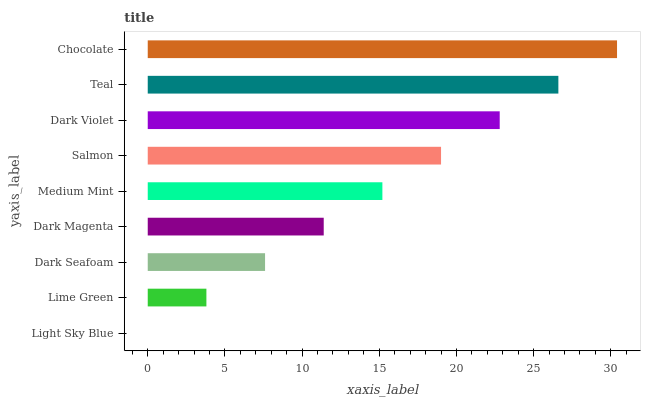Is Light Sky Blue the minimum?
Answer yes or no. Yes. Is Chocolate the maximum?
Answer yes or no. Yes. Is Lime Green the minimum?
Answer yes or no. No. Is Lime Green the maximum?
Answer yes or no. No. Is Lime Green greater than Light Sky Blue?
Answer yes or no. Yes. Is Light Sky Blue less than Lime Green?
Answer yes or no. Yes. Is Light Sky Blue greater than Lime Green?
Answer yes or no. No. Is Lime Green less than Light Sky Blue?
Answer yes or no. No. Is Medium Mint the high median?
Answer yes or no. Yes. Is Medium Mint the low median?
Answer yes or no. Yes. Is Teal the high median?
Answer yes or no. No. Is Dark Magenta the low median?
Answer yes or no. No. 